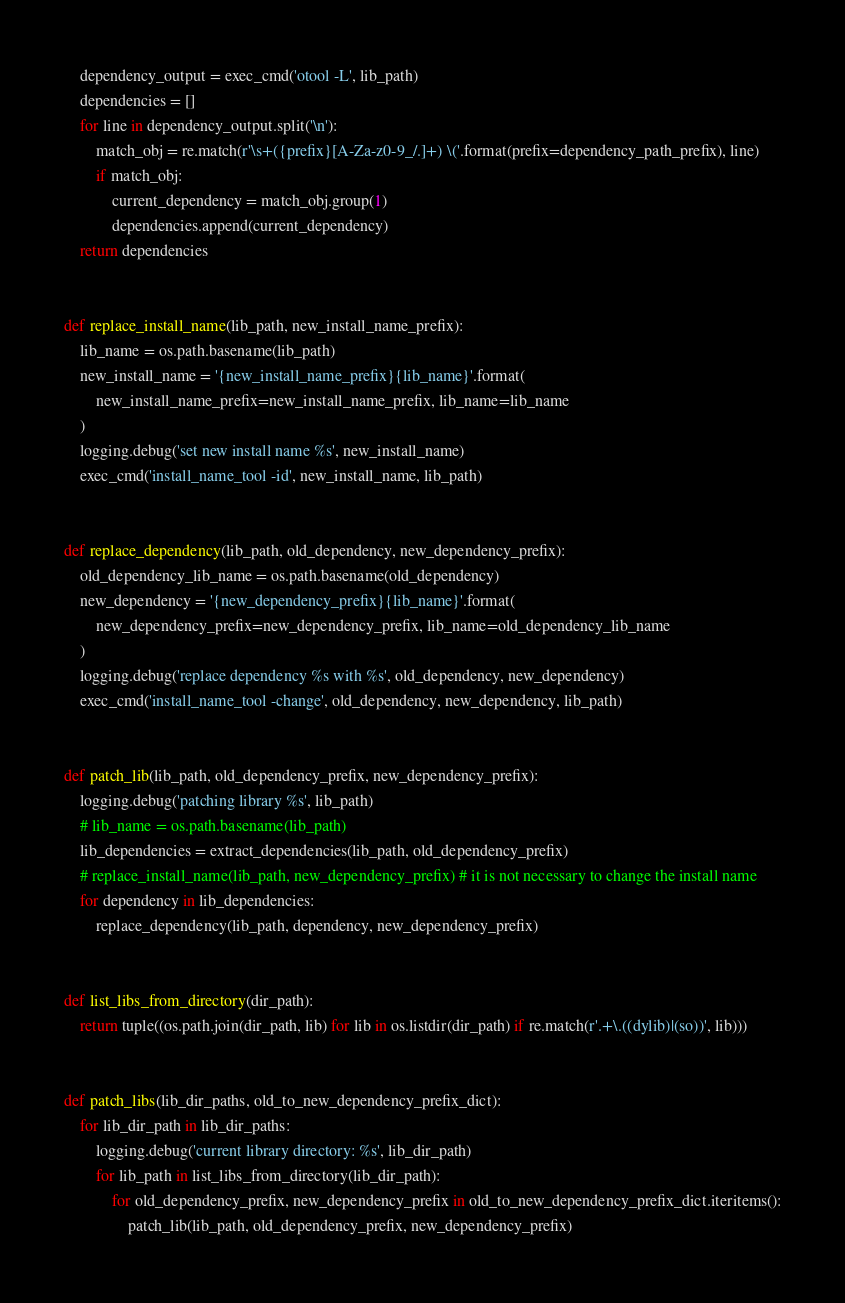<code> <loc_0><loc_0><loc_500><loc_500><_Python_>    dependency_output = exec_cmd('otool -L', lib_path)
    dependencies = []
    for line in dependency_output.split('\n'):
        match_obj = re.match(r'\s+({prefix}[A-Za-z0-9_/.]+) \('.format(prefix=dependency_path_prefix), line)
        if match_obj:
            current_dependency = match_obj.group(1)
            dependencies.append(current_dependency)
    return dependencies


def replace_install_name(lib_path, new_install_name_prefix):
    lib_name = os.path.basename(lib_path)
    new_install_name = '{new_install_name_prefix}{lib_name}'.format(
        new_install_name_prefix=new_install_name_prefix, lib_name=lib_name
    )
    logging.debug('set new install name %s', new_install_name)
    exec_cmd('install_name_tool -id', new_install_name, lib_path)


def replace_dependency(lib_path, old_dependency, new_dependency_prefix):
    old_dependency_lib_name = os.path.basename(old_dependency)
    new_dependency = '{new_dependency_prefix}{lib_name}'.format(
        new_dependency_prefix=new_dependency_prefix, lib_name=old_dependency_lib_name
    )
    logging.debug('replace dependency %s with %s', old_dependency, new_dependency)
    exec_cmd('install_name_tool -change', old_dependency, new_dependency, lib_path)


def patch_lib(lib_path, old_dependency_prefix, new_dependency_prefix):
    logging.debug('patching library %s', lib_path)
    # lib_name = os.path.basename(lib_path)
    lib_dependencies = extract_dependencies(lib_path, old_dependency_prefix)
    # replace_install_name(lib_path, new_dependency_prefix) # it is not necessary to change the install name
    for dependency in lib_dependencies:
        replace_dependency(lib_path, dependency, new_dependency_prefix)


def list_libs_from_directory(dir_path):
    return tuple((os.path.join(dir_path, lib) for lib in os.listdir(dir_path) if re.match(r'.+\.((dylib)|(so))', lib)))


def patch_libs(lib_dir_paths, old_to_new_dependency_prefix_dict):
    for lib_dir_path in lib_dir_paths:
        logging.debug('current library directory: %s', lib_dir_path)
        for lib_path in list_libs_from_directory(lib_dir_path):
            for old_dependency_prefix, new_dependency_prefix in old_to_new_dependency_prefix_dict.iteritems():
                patch_lib(lib_path, old_dependency_prefix, new_dependency_prefix)
</code> 